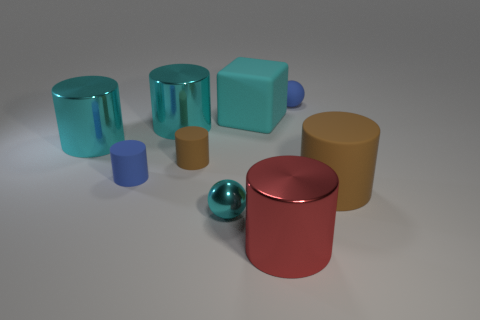Subtract all brown cylinders. How many cylinders are left? 4 Subtract all large cyan cylinders. How many cylinders are left? 4 Subtract all yellow cylinders. Subtract all red blocks. How many cylinders are left? 6 Add 1 small gray cubes. How many objects exist? 10 Subtract all cylinders. How many objects are left? 3 Subtract 0 purple cylinders. How many objects are left? 9 Subtract all tiny blue matte spheres. Subtract all tiny blue matte cylinders. How many objects are left? 7 Add 5 big red metallic objects. How many big red metallic objects are left? 6 Add 6 cyan matte things. How many cyan matte things exist? 7 